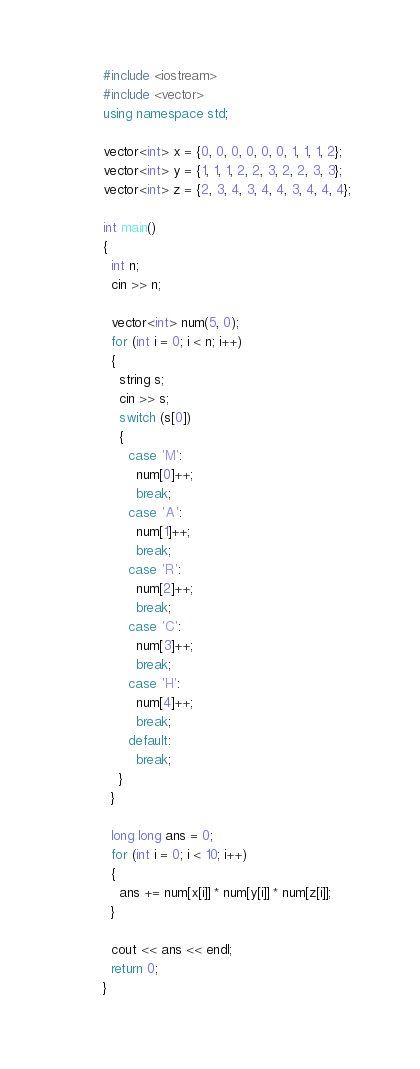<code> <loc_0><loc_0><loc_500><loc_500><_C++_>#include <iostream>
#include <vector>
using namespace std;

vector<int> x = {0, 0, 0, 0, 0, 0, 1, 1, 1, 2};
vector<int> y = {1, 1, 1, 2, 2, 3, 2, 2, 3, 3};
vector<int> z = {2, 3, 4, 3, 4, 4, 3, 4, 4, 4};

int main()
{
  int n;
  cin >> n;

  vector<int> num(5, 0);
  for (int i = 0; i < n; i++)
  {
    string s;
    cin >> s;
    switch (s[0])
    {
      case 'M':
        num[0]++;
        break;
      case 'A':
        num[1]++;
        break;
      case 'R':
        num[2]++;
        break;
      case 'C':
        num[3]++;
        break;
      case 'H':
        num[4]++;
        break;
      default:
        break;
    }
  }

  long long ans = 0;
  for (int i = 0; i < 10; i++)
  {
    ans += num[x[i]] * num[y[i]] * num[z[i]];
  }

  cout << ans << endl;
  return 0;
}</code> 